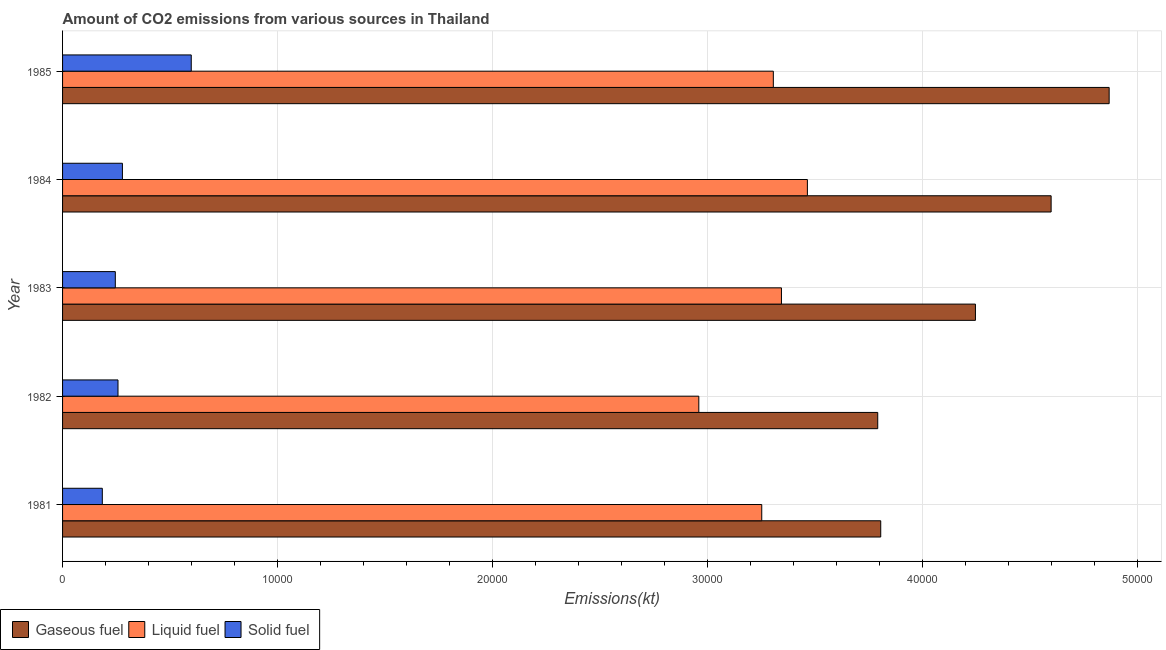How many different coloured bars are there?
Ensure brevity in your answer.  3. How many groups of bars are there?
Offer a very short reply. 5. Are the number of bars per tick equal to the number of legend labels?
Provide a short and direct response. Yes. What is the label of the 4th group of bars from the top?
Provide a succinct answer. 1982. What is the amount of co2 emissions from liquid fuel in 1984?
Your answer should be very brief. 3.46e+04. Across all years, what is the maximum amount of co2 emissions from gaseous fuel?
Offer a terse response. 4.87e+04. Across all years, what is the minimum amount of co2 emissions from gaseous fuel?
Ensure brevity in your answer.  3.79e+04. What is the total amount of co2 emissions from liquid fuel in the graph?
Ensure brevity in your answer.  1.63e+05. What is the difference between the amount of co2 emissions from liquid fuel in 1984 and that in 1985?
Provide a short and direct response. 1584.14. What is the difference between the amount of co2 emissions from gaseous fuel in 1984 and the amount of co2 emissions from solid fuel in 1983?
Offer a very short reply. 4.35e+04. What is the average amount of co2 emissions from solid fuel per year?
Your response must be concise. 3129.42. In the year 1983, what is the difference between the amount of co2 emissions from liquid fuel and amount of co2 emissions from gaseous fuel?
Provide a short and direct response. -9020.82. What is the ratio of the amount of co2 emissions from gaseous fuel in 1982 to that in 1984?
Provide a short and direct response. 0.82. Is the amount of co2 emissions from liquid fuel in 1981 less than that in 1985?
Offer a very short reply. Yes. What is the difference between the highest and the second highest amount of co2 emissions from solid fuel?
Offer a terse response. 3201.29. What is the difference between the highest and the lowest amount of co2 emissions from gaseous fuel?
Ensure brevity in your answer.  1.08e+04. What does the 2nd bar from the top in 1983 represents?
Your answer should be very brief. Liquid fuel. What does the 1st bar from the bottom in 1982 represents?
Ensure brevity in your answer.  Gaseous fuel. Is it the case that in every year, the sum of the amount of co2 emissions from gaseous fuel and amount of co2 emissions from liquid fuel is greater than the amount of co2 emissions from solid fuel?
Keep it short and to the point. Yes. Are all the bars in the graph horizontal?
Provide a short and direct response. Yes. What is the difference between two consecutive major ticks on the X-axis?
Ensure brevity in your answer.  10000. Are the values on the major ticks of X-axis written in scientific E-notation?
Ensure brevity in your answer.  No. Does the graph contain any zero values?
Provide a short and direct response. No. Does the graph contain grids?
Your response must be concise. Yes. Where does the legend appear in the graph?
Provide a succinct answer. Bottom left. How many legend labels are there?
Offer a terse response. 3. How are the legend labels stacked?
Offer a very short reply. Horizontal. What is the title of the graph?
Offer a very short reply. Amount of CO2 emissions from various sources in Thailand. Does "Coal sources" appear as one of the legend labels in the graph?
Your answer should be compact. No. What is the label or title of the X-axis?
Provide a short and direct response. Emissions(kt). What is the label or title of the Y-axis?
Make the answer very short. Year. What is the Emissions(kt) of Gaseous fuel in 1981?
Your answer should be compact. 3.80e+04. What is the Emissions(kt) in Liquid fuel in 1981?
Provide a short and direct response. 3.25e+04. What is the Emissions(kt) in Solid fuel in 1981?
Your answer should be compact. 1848.17. What is the Emissions(kt) of Gaseous fuel in 1982?
Your response must be concise. 3.79e+04. What is the Emissions(kt) of Liquid fuel in 1982?
Ensure brevity in your answer.  2.96e+04. What is the Emissions(kt) in Solid fuel in 1982?
Ensure brevity in your answer.  2577.9. What is the Emissions(kt) of Gaseous fuel in 1983?
Keep it short and to the point. 4.25e+04. What is the Emissions(kt) in Liquid fuel in 1983?
Make the answer very short. 3.34e+04. What is the Emissions(kt) in Solid fuel in 1983?
Offer a terse response. 2453.22. What is the Emissions(kt) of Gaseous fuel in 1984?
Your response must be concise. 4.60e+04. What is the Emissions(kt) in Liquid fuel in 1984?
Make the answer very short. 3.46e+04. What is the Emissions(kt) in Solid fuel in 1984?
Provide a succinct answer. 2783.25. What is the Emissions(kt) in Gaseous fuel in 1985?
Provide a succinct answer. 4.87e+04. What is the Emissions(kt) of Liquid fuel in 1985?
Provide a succinct answer. 3.31e+04. What is the Emissions(kt) of Solid fuel in 1985?
Provide a succinct answer. 5984.54. Across all years, what is the maximum Emissions(kt) of Gaseous fuel?
Offer a terse response. 4.87e+04. Across all years, what is the maximum Emissions(kt) of Liquid fuel?
Make the answer very short. 3.46e+04. Across all years, what is the maximum Emissions(kt) of Solid fuel?
Provide a short and direct response. 5984.54. Across all years, what is the minimum Emissions(kt) of Gaseous fuel?
Keep it short and to the point. 3.79e+04. Across all years, what is the minimum Emissions(kt) of Liquid fuel?
Give a very brief answer. 2.96e+04. Across all years, what is the minimum Emissions(kt) of Solid fuel?
Keep it short and to the point. 1848.17. What is the total Emissions(kt) of Gaseous fuel in the graph?
Make the answer very short. 2.13e+05. What is the total Emissions(kt) of Liquid fuel in the graph?
Your response must be concise. 1.63e+05. What is the total Emissions(kt) in Solid fuel in the graph?
Give a very brief answer. 1.56e+04. What is the difference between the Emissions(kt) in Gaseous fuel in 1981 and that in 1982?
Keep it short and to the point. 139.35. What is the difference between the Emissions(kt) in Liquid fuel in 1981 and that in 1982?
Provide a succinct answer. 2926.27. What is the difference between the Emissions(kt) in Solid fuel in 1981 and that in 1982?
Provide a succinct answer. -729.73. What is the difference between the Emissions(kt) in Gaseous fuel in 1981 and that in 1983?
Your response must be concise. -4404.07. What is the difference between the Emissions(kt) of Liquid fuel in 1981 and that in 1983?
Offer a very short reply. -916.75. What is the difference between the Emissions(kt) of Solid fuel in 1981 and that in 1983?
Keep it short and to the point. -605.05. What is the difference between the Emissions(kt) in Gaseous fuel in 1981 and that in 1984?
Keep it short and to the point. -7924.39. What is the difference between the Emissions(kt) of Liquid fuel in 1981 and that in 1984?
Give a very brief answer. -2123.19. What is the difference between the Emissions(kt) of Solid fuel in 1981 and that in 1984?
Your answer should be compact. -935.09. What is the difference between the Emissions(kt) of Gaseous fuel in 1981 and that in 1985?
Provide a succinct answer. -1.06e+04. What is the difference between the Emissions(kt) in Liquid fuel in 1981 and that in 1985?
Your answer should be compact. -539.05. What is the difference between the Emissions(kt) in Solid fuel in 1981 and that in 1985?
Your response must be concise. -4136.38. What is the difference between the Emissions(kt) of Gaseous fuel in 1982 and that in 1983?
Your answer should be compact. -4543.41. What is the difference between the Emissions(kt) in Liquid fuel in 1982 and that in 1983?
Give a very brief answer. -3843.02. What is the difference between the Emissions(kt) of Solid fuel in 1982 and that in 1983?
Your response must be concise. 124.68. What is the difference between the Emissions(kt) of Gaseous fuel in 1982 and that in 1984?
Your response must be concise. -8063.73. What is the difference between the Emissions(kt) in Liquid fuel in 1982 and that in 1984?
Make the answer very short. -5049.46. What is the difference between the Emissions(kt) in Solid fuel in 1982 and that in 1984?
Ensure brevity in your answer.  -205.35. What is the difference between the Emissions(kt) of Gaseous fuel in 1982 and that in 1985?
Provide a succinct answer. -1.08e+04. What is the difference between the Emissions(kt) in Liquid fuel in 1982 and that in 1985?
Your answer should be compact. -3465.32. What is the difference between the Emissions(kt) of Solid fuel in 1982 and that in 1985?
Provide a short and direct response. -3406.64. What is the difference between the Emissions(kt) of Gaseous fuel in 1983 and that in 1984?
Your answer should be compact. -3520.32. What is the difference between the Emissions(kt) in Liquid fuel in 1983 and that in 1984?
Offer a terse response. -1206.44. What is the difference between the Emissions(kt) of Solid fuel in 1983 and that in 1984?
Keep it short and to the point. -330.03. What is the difference between the Emissions(kt) of Gaseous fuel in 1983 and that in 1985?
Keep it short and to the point. -6219.23. What is the difference between the Emissions(kt) of Liquid fuel in 1983 and that in 1985?
Offer a terse response. 377.7. What is the difference between the Emissions(kt) of Solid fuel in 1983 and that in 1985?
Your response must be concise. -3531.32. What is the difference between the Emissions(kt) of Gaseous fuel in 1984 and that in 1985?
Your response must be concise. -2698.91. What is the difference between the Emissions(kt) in Liquid fuel in 1984 and that in 1985?
Make the answer very short. 1584.14. What is the difference between the Emissions(kt) of Solid fuel in 1984 and that in 1985?
Your answer should be compact. -3201.29. What is the difference between the Emissions(kt) in Gaseous fuel in 1981 and the Emissions(kt) in Liquid fuel in 1982?
Your response must be concise. 8459.77. What is the difference between the Emissions(kt) in Gaseous fuel in 1981 and the Emissions(kt) in Solid fuel in 1982?
Make the answer very short. 3.55e+04. What is the difference between the Emissions(kt) of Liquid fuel in 1981 and the Emissions(kt) of Solid fuel in 1982?
Make the answer very short. 2.99e+04. What is the difference between the Emissions(kt) of Gaseous fuel in 1981 and the Emissions(kt) of Liquid fuel in 1983?
Your answer should be very brief. 4616.75. What is the difference between the Emissions(kt) in Gaseous fuel in 1981 and the Emissions(kt) in Solid fuel in 1983?
Provide a short and direct response. 3.56e+04. What is the difference between the Emissions(kt) in Liquid fuel in 1981 and the Emissions(kt) in Solid fuel in 1983?
Offer a very short reply. 3.01e+04. What is the difference between the Emissions(kt) in Gaseous fuel in 1981 and the Emissions(kt) in Liquid fuel in 1984?
Provide a succinct answer. 3410.31. What is the difference between the Emissions(kt) of Gaseous fuel in 1981 and the Emissions(kt) of Solid fuel in 1984?
Your response must be concise. 3.53e+04. What is the difference between the Emissions(kt) of Liquid fuel in 1981 and the Emissions(kt) of Solid fuel in 1984?
Your answer should be very brief. 2.97e+04. What is the difference between the Emissions(kt) in Gaseous fuel in 1981 and the Emissions(kt) in Liquid fuel in 1985?
Provide a succinct answer. 4994.45. What is the difference between the Emissions(kt) of Gaseous fuel in 1981 and the Emissions(kt) of Solid fuel in 1985?
Keep it short and to the point. 3.21e+04. What is the difference between the Emissions(kt) in Liquid fuel in 1981 and the Emissions(kt) in Solid fuel in 1985?
Your answer should be compact. 2.65e+04. What is the difference between the Emissions(kt) in Gaseous fuel in 1982 and the Emissions(kt) in Liquid fuel in 1983?
Give a very brief answer. 4477.41. What is the difference between the Emissions(kt) in Gaseous fuel in 1982 and the Emissions(kt) in Solid fuel in 1983?
Offer a very short reply. 3.55e+04. What is the difference between the Emissions(kt) of Liquid fuel in 1982 and the Emissions(kt) of Solid fuel in 1983?
Ensure brevity in your answer.  2.71e+04. What is the difference between the Emissions(kt) in Gaseous fuel in 1982 and the Emissions(kt) in Liquid fuel in 1984?
Give a very brief answer. 3270.96. What is the difference between the Emissions(kt) of Gaseous fuel in 1982 and the Emissions(kt) of Solid fuel in 1984?
Offer a very short reply. 3.51e+04. What is the difference between the Emissions(kt) of Liquid fuel in 1982 and the Emissions(kt) of Solid fuel in 1984?
Your response must be concise. 2.68e+04. What is the difference between the Emissions(kt) of Gaseous fuel in 1982 and the Emissions(kt) of Liquid fuel in 1985?
Offer a terse response. 4855.11. What is the difference between the Emissions(kt) in Gaseous fuel in 1982 and the Emissions(kt) in Solid fuel in 1985?
Your answer should be very brief. 3.19e+04. What is the difference between the Emissions(kt) in Liquid fuel in 1982 and the Emissions(kt) in Solid fuel in 1985?
Offer a very short reply. 2.36e+04. What is the difference between the Emissions(kt) of Gaseous fuel in 1983 and the Emissions(kt) of Liquid fuel in 1984?
Give a very brief answer. 7814.38. What is the difference between the Emissions(kt) in Gaseous fuel in 1983 and the Emissions(kt) in Solid fuel in 1984?
Your answer should be compact. 3.97e+04. What is the difference between the Emissions(kt) of Liquid fuel in 1983 and the Emissions(kt) of Solid fuel in 1984?
Your answer should be compact. 3.06e+04. What is the difference between the Emissions(kt) in Gaseous fuel in 1983 and the Emissions(kt) in Liquid fuel in 1985?
Keep it short and to the point. 9398.52. What is the difference between the Emissions(kt) of Gaseous fuel in 1983 and the Emissions(kt) of Solid fuel in 1985?
Ensure brevity in your answer.  3.65e+04. What is the difference between the Emissions(kt) in Liquid fuel in 1983 and the Emissions(kt) in Solid fuel in 1985?
Make the answer very short. 2.74e+04. What is the difference between the Emissions(kt) of Gaseous fuel in 1984 and the Emissions(kt) of Liquid fuel in 1985?
Give a very brief answer. 1.29e+04. What is the difference between the Emissions(kt) of Gaseous fuel in 1984 and the Emissions(kt) of Solid fuel in 1985?
Ensure brevity in your answer.  4.00e+04. What is the difference between the Emissions(kt) of Liquid fuel in 1984 and the Emissions(kt) of Solid fuel in 1985?
Provide a succinct answer. 2.87e+04. What is the average Emissions(kt) in Gaseous fuel per year?
Make the answer very short. 4.26e+04. What is the average Emissions(kt) of Liquid fuel per year?
Ensure brevity in your answer.  3.26e+04. What is the average Emissions(kt) in Solid fuel per year?
Provide a succinct answer. 3129.42. In the year 1981, what is the difference between the Emissions(kt) of Gaseous fuel and Emissions(kt) of Liquid fuel?
Ensure brevity in your answer.  5533.5. In the year 1981, what is the difference between the Emissions(kt) in Gaseous fuel and Emissions(kt) in Solid fuel?
Offer a very short reply. 3.62e+04. In the year 1981, what is the difference between the Emissions(kt) of Liquid fuel and Emissions(kt) of Solid fuel?
Ensure brevity in your answer.  3.07e+04. In the year 1982, what is the difference between the Emissions(kt) in Gaseous fuel and Emissions(kt) in Liquid fuel?
Make the answer very short. 8320.42. In the year 1982, what is the difference between the Emissions(kt) in Gaseous fuel and Emissions(kt) in Solid fuel?
Offer a very short reply. 3.53e+04. In the year 1982, what is the difference between the Emissions(kt) of Liquid fuel and Emissions(kt) of Solid fuel?
Make the answer very short. 2.70e+04. In the year 1983, what is the difference between the Emissions(kt) of Gaseous fuel and Emissions(kt) of Liquid fuel?
Your response must be concise. 9020.82. In the year 1983, what is the difference between the Emissions(kt) of Gaseous fuel and Emissions(kt) of Solid fuel?
Keep it short and to the point. 4.00e+04. In the year 1983, what is the difference between the Emissions(kt) of Liquid fuel and Emissions(kt) of Solid fuel?
Provide a short and direct response. 3.10e+04. In the year 1984, what is the difference between the Emissions(kt) in Gaseous fuel and Emissions(kt) in Liquid fuel?
Ensure brevity in your answer.  1.13e+04. In the year 1984, what is the difference between the Emissions(kt) in Gaseous fuel and Emissions(kt) in Solid fuel?
Ensure brevity in your answer.  4.32e+04. In the year 1984, what is the difference between the Emissions(kt) of Liquid fuel and Emissions(kt) of Solid fuel?
Offer a terse response. 3.19e+04. In the year 1985, what is the difference between the Emissions(kt) of Gaseous fuel and Emissions(kt) of Liquid fuel?
Provide a short and direct response. 1.56e+04. In the year 1985, what is the difference between the Emissions(kt) of Gaseous fuel and Emissions(kt) of Solid fuel?
Provide a succinct answer. 4.27e+04. In the year 1985, what is the difference between the Emissions(kt) of Liquid fuel and Emissions(kt) of Solid fuel?
Provide a short and direct response. 2.71e+04. What is the ratio of the Emissions(kt) in Liquid fuel in 1981 to that in 1982?
Give a very brief answer. 1.1. What is the ratio of the Emissions(kt) of Solid fuel in 1981 to that in 1982?
Make the answer very short. 0.72. What is the ratio of the Emissions(kt) of Gaseous fuel in 1981 to that in 1983?
Keep it short and to the point. 0.9. What is the ratio of the Emissions(kt) of Liquid fuel in 1981 to that in 1983?
Offer a very short reply. 0.97. What is the ratio of the Emissions(kt) in Solid fuel in 1981 to that in 1983?
Provide a short and direct response. 0.75. What is the ratio of the Emissions(kt) of Gaseous fuel in 1981 to that in 1984?
Offer a terse response. 0.83. What is the ratio of the Emissions(kt) in Liquid fuel in 1981 to that in 1984?
Offer a terse response. 0.94. What is the ratio of the Emissions(kt) of Solid fuel in 1981 to that in 1984?
Provide a succinct answer. 0.66. What is the ratio of the Emissions(kt) of Gaseous fuel in 1981 to that in 1985?
Make the answer very short. 0.78. What is the ratio of the Emissions(kt) in Liquid fuel in 1981 to that in 1985?
Provide a short and direct response. 0.98. What is the ratio of the Emissions(kt) of Solid fuel in 1981 to that in 1985?
Give a very brief answer. 0.31. What is the ratio of the Emissions(kt) in Gaseous fuel in 1982 to that in 1983?
Your response must be concise. 0.89. What is the ratio of the Emissions(kt) in Liquid fuel in 1982 to that in 1983?
Offer a terse response. 0.89. What is the ratio of the Emissions(kt) of Solid fuel in 1982 to that in 1983?
Provide a succinct answer. 1.05. What is the ratio of the Emissions(kt) in Gaseous fuel in 1982 to that in 1984?
Keep it short and to the point. 0.82. What is the ratio of the Emissions(kt) in Liquid fuel in 1982 to that in 1984?
Offer a terse response. 0.85. What is the ratio of the Emissions(kt) of Solid fuel in 1982 to that in 1984?
Keep it short and to the point. 0.93. What is the ratio of the Emissions(kt) of Gaseous fuel in 1982 to that in 1985?
Your answer should be very brief. 0.78. What is the ratio of the Emissions(kt) of Liquid fuel in 1982 to that in 1985?
Your answer should be compact. 0.9. What is the ratio of the Emissions(kt) of Solid fuel in 1982 to that in 1985?
Offer a very short reply. 0.43. What is the ratio of the Emissions(kt) in Gaseous fuel in 1983 to that in 1984?
Make the answer very short. 0.92. What is the ratio of the Emissions(kt) of Liquid fuel in 1983 to that in 1984?
Your response must be concise. 0.97. What is the ratio of the Emissions(kt) in Solid fuel in 1983 to that in 1984?
Keep it short and to the point. 0.88. What is the ratio of the Emissions(kt) in Gaseous fuel in 1983 to that in 1985?
Ensure brevity in your answer.  0.87. What is the ratio of the Emissions(kt) in Liquid fuel in 1983 to that in 1985?
Offer a very short reply. 1.01. What is the ratio of the Emissions(kt) of Solid fuel in 1983 to that in 1985?
Make the answer very short. 0.41. What is the ratio of the Emissions(kt) in Gaseous fuel in 1984 to that in 1985?
Give a very brief answer. 0.94. What is the ratio of the Emissions(kt) of Liquid fuel in 1984 to that in 1985?
Provide a short and direct response. 1.05. What is the ratio of the Emissions(kt) in Solid fuel in 1984 to that in 1985?
Keep it short and to the point. 0.47. What is the difference between the highest and the second highest Emissions(kt) in Gaseous fuel?
Your answer should be compact. 2698.91. What is the difference between the highest and the second highest Emissions(kt) in Liquid fuel?
Give a very brief answer. 1206.44. What is the difference between the highest and the second highest Emissions(kt) of Solid fuel?
Give a very brief answer. 3201.29. What is the difference between the highest and the lowest Emissions(kt) in Gaseous fuel?
Provide a short and direct response. 1.08e+04. What is the difference between the highest and the lowest Emissions(kt) in Liquid fuel?
Ensure brevity in your answer.  5049.46. What is the difference between the highest and the lowest Emissions(kt) in Solid fuel?
Provide a short and direct response. 4136.38. 